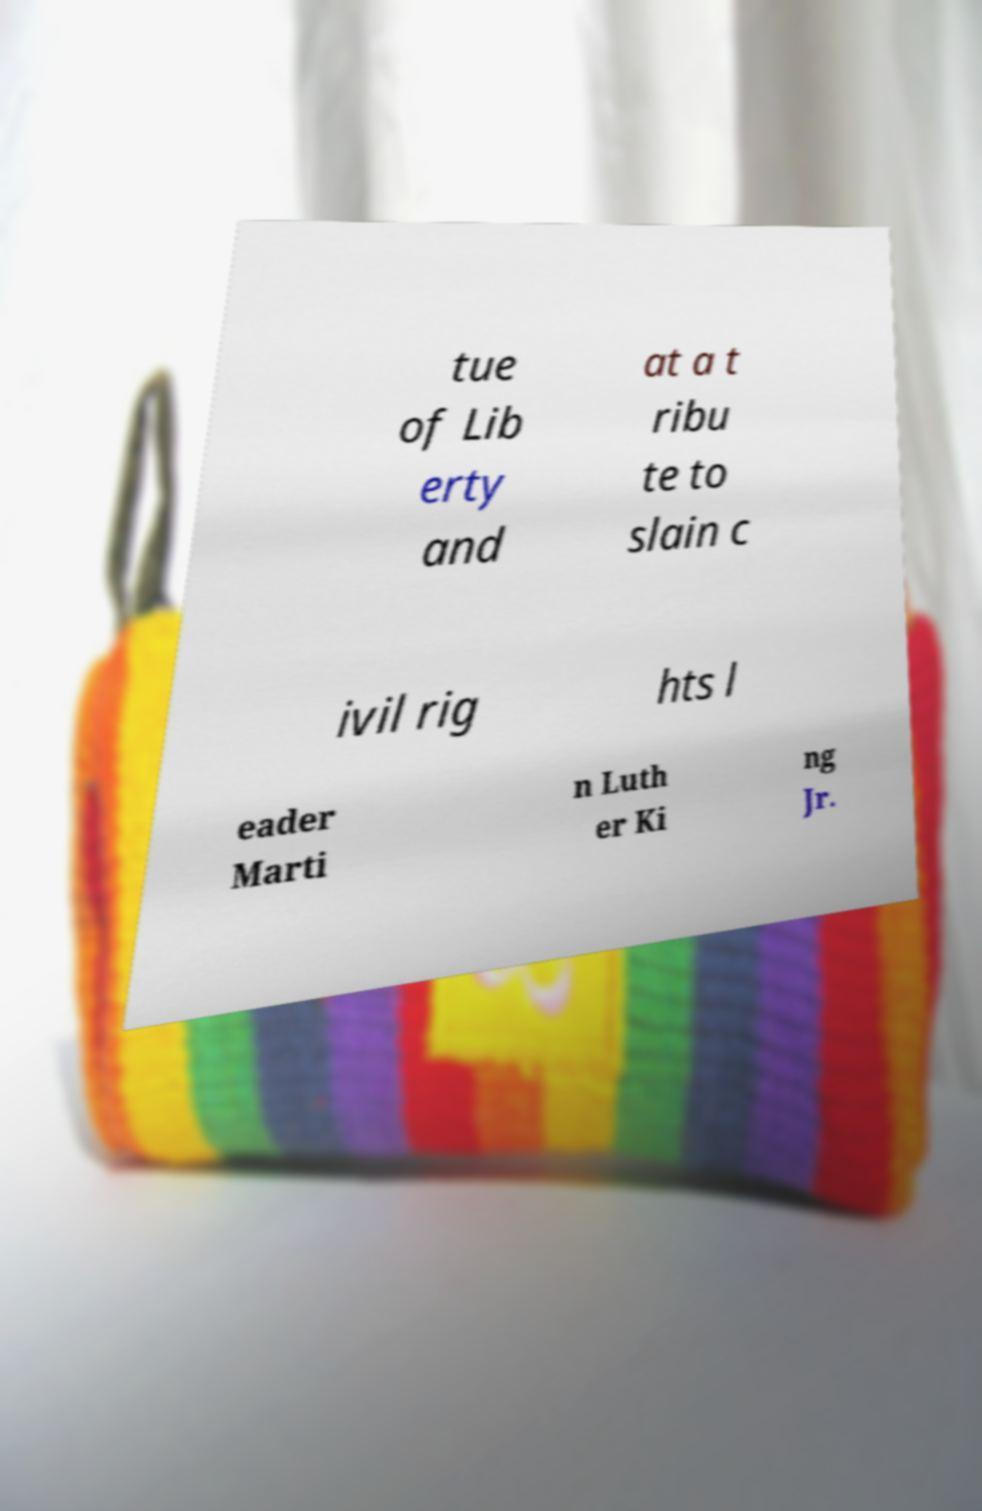Can you accurately transcribe the text from the provided image for me? tue of Lib erty and at a t ribu te to slain c ivil rig hts l eader Marti n Luth er Ki ng Jr. 